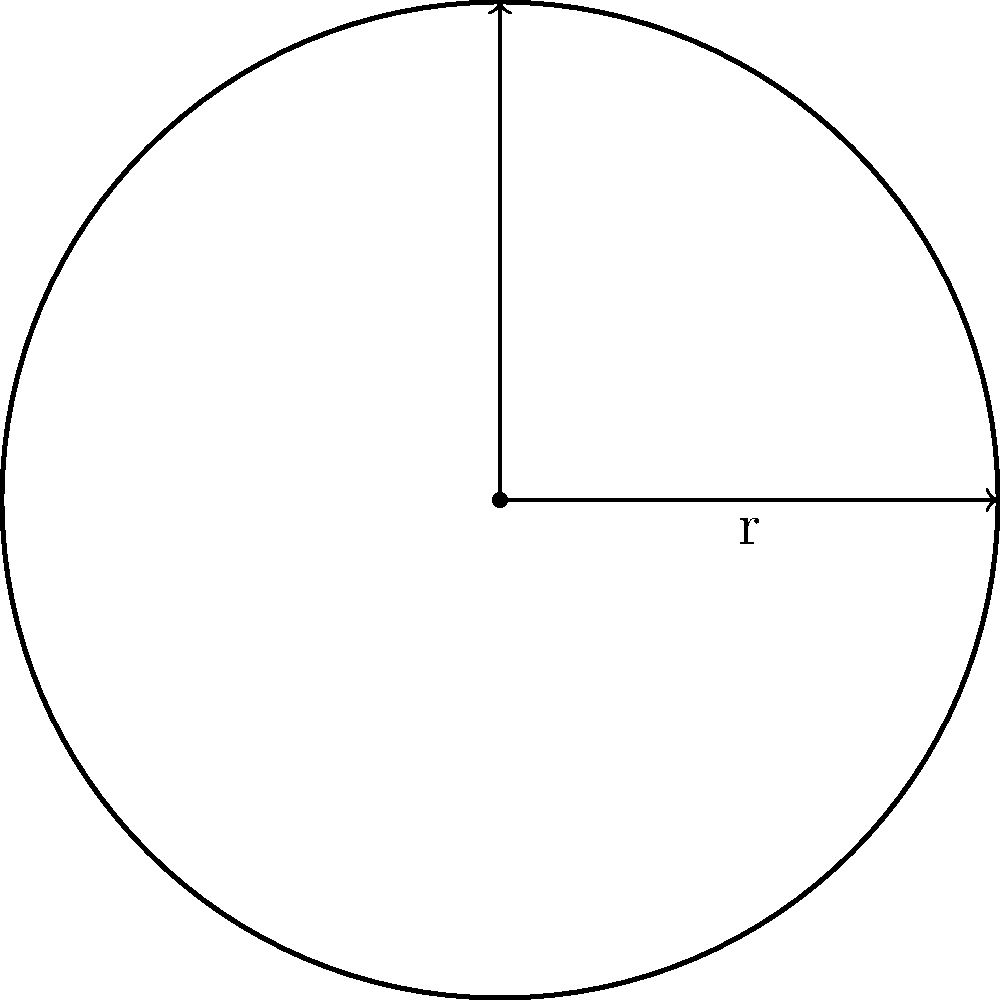A standard golf ball has a diameter of 1.68 inches. Using the formula for the volume of a sphere, $V = \frac{4}{3}\pi r^3$, calculate the volume of a golf ball in cubic inches. Round your answer to two decimal places. To calculate the volume of a golf ball, we'll follow these steps:

1. Identify the given information:
   - Diameter of the golf ball = 1.68 inches
   - Formula for the volume of a sphere: $V = \frac{4}{3}\pi r^3$

2. Calculate the radius:
   Radius = Diameter ÷ 2
   $r = 1.68 \div 2 = 0.84$ inches

3. Substitute the radius into the volume formula:
   $V = \frac{4}{3}\pi (0.84)^3$

4. Calculate the result:
   $V = \frac{4}{3}\pi (0.592704)$
   $V = 4.1887902 \times 0.592704$
   $V = 2.48332$ cubic inches

5. Round the result to two decimal places:
   $V \approx 2.48$ cubic inches
Answer: 2.48 cubic inches 